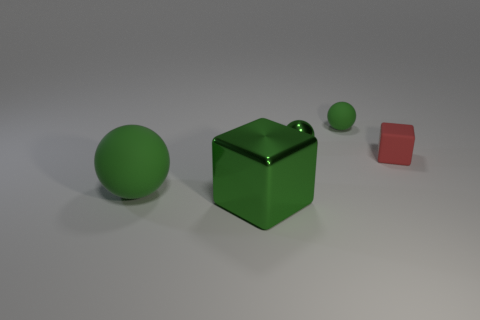How many things are small rubber things that are right of the small green matte ball or tiny things?
Provide a short and direct response. 3. How many tiny purple things have the same material as the tiny block?
Offer a terse response. 0. What shape is the big shiny thing that is the same color as the large matte thing?
Your answer should be compact. Cube. Is there a green thing of the same shape as the red matte object?
Your answer should be compact. Yes. What is the shape of the red rubber thing that is the same size as the green metal ball?
Offer a terse response. Cube. There is a tiny shiny thing; is its color the same as the cube that is in front of the red rubber block?
Offer a terse response. Yes. There is a green matte thing that is left of the small rubber ball; how many big green blocks are in front of it?
Provide a short and direct response. 1. There is a rubber thing that is both in front of the small green rubber object and left of the small red block; what size is it?
Keep it short and to the point. Large. Are there any green shiny blocks of the same size as the red rubber cube?
Give a very brief answer. No. Is the number of objects that are in front of the large metallic thing greater than the number of tiny things that are behind the small green metal ball?
Offer a very short reply. No. 